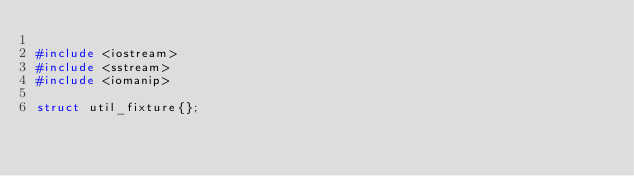Convert code to text. <code><loc_0><loc_0><loc_500><loc_500><_C++_>
#include <iostream>
#include <sstream>
#include <iomanip>

struct util_fixture{};

</code> 